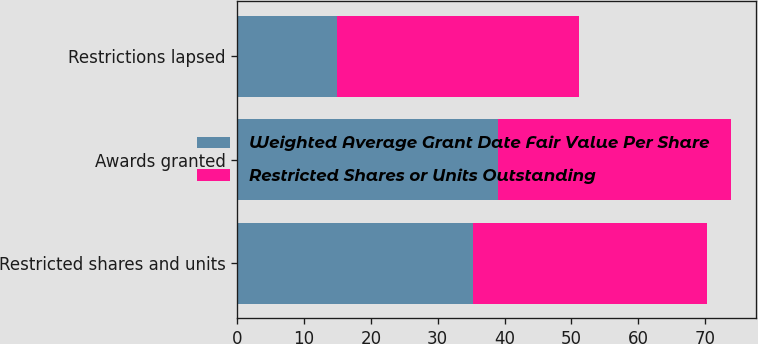Convert chart to OTSL. <chart><loc_0><loc_0><loc_500><loc_500><stacked_bar_chart><ecel><fcel>Restricted shares and units<fcel>Awards granted<fcel>Restrictions lapsed<nl><fcel>Weighted Average Grant Date Fair Value Per Share<fcel>35.35<fcel>39<fcel>15<nl><fcel>Restricted Shares or Units Outstanding<fcel>34.97<fcel>34.89<fcel>36.12<nl></chart> 